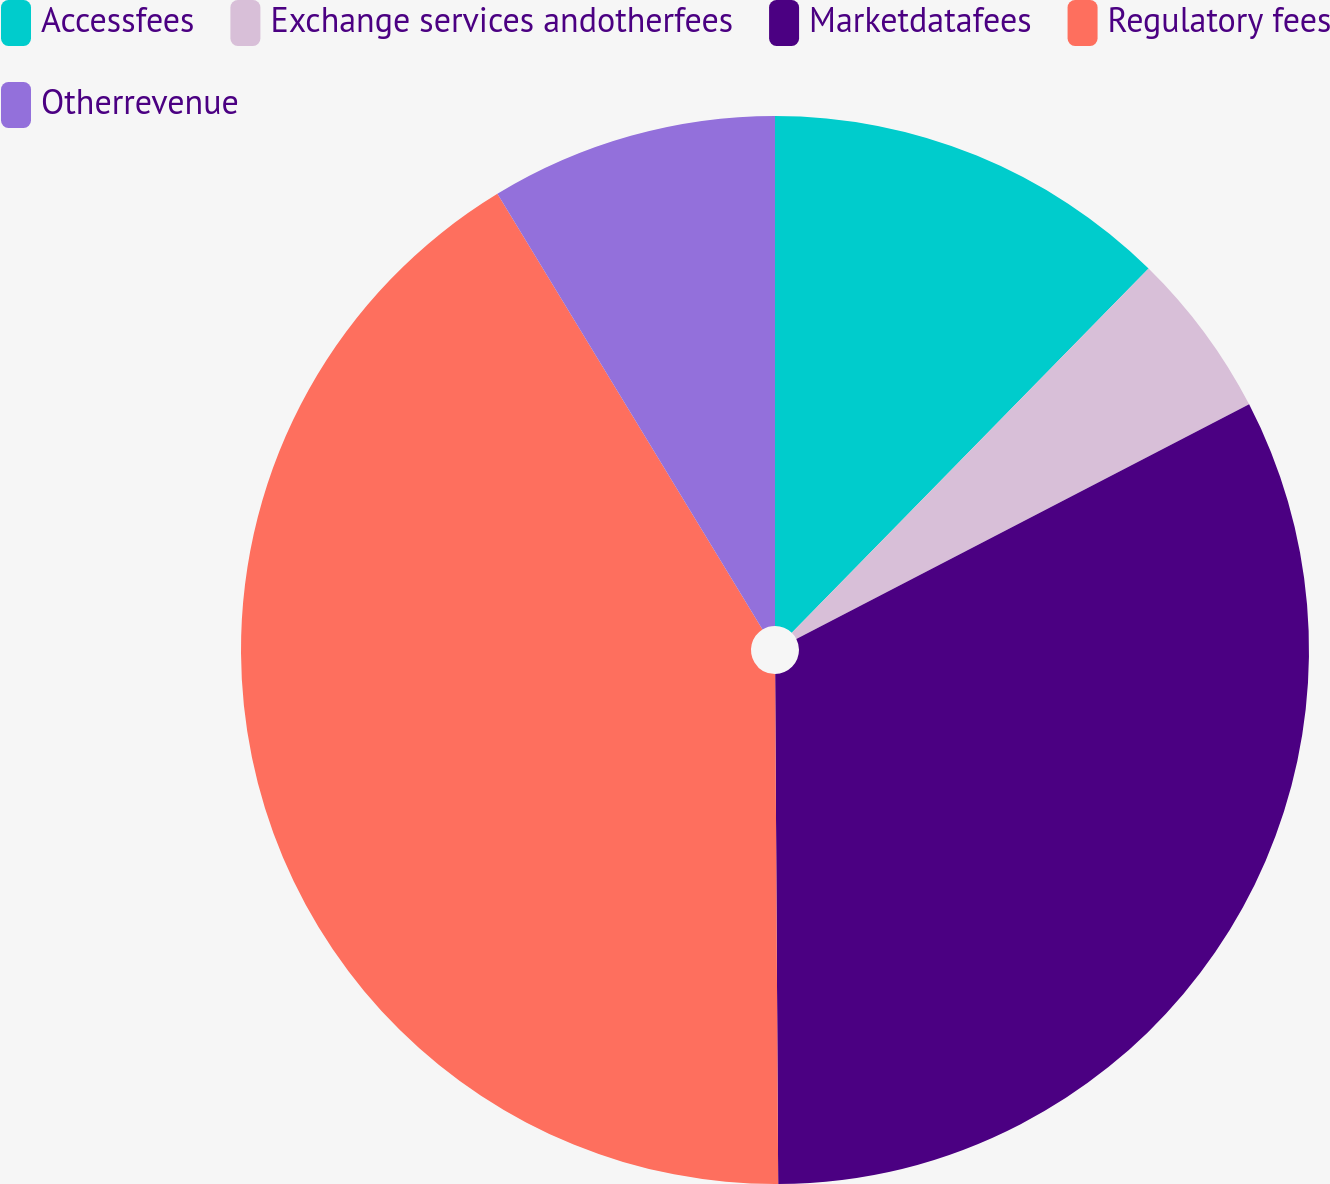<chart> <loc_0><loc_0><loc_500><loc_500><pie_chart><fcel>Accessfees<fcel>Exchange services andotherfees<fcel>Marketdatafees<fcel>Regulatory fees<fcel>Otherrevenue<nl><fcel>12.33%<fcel>5.06%<fcel>32.51%<fcel>41.39%<fcel>8.7%<nl></chart> 